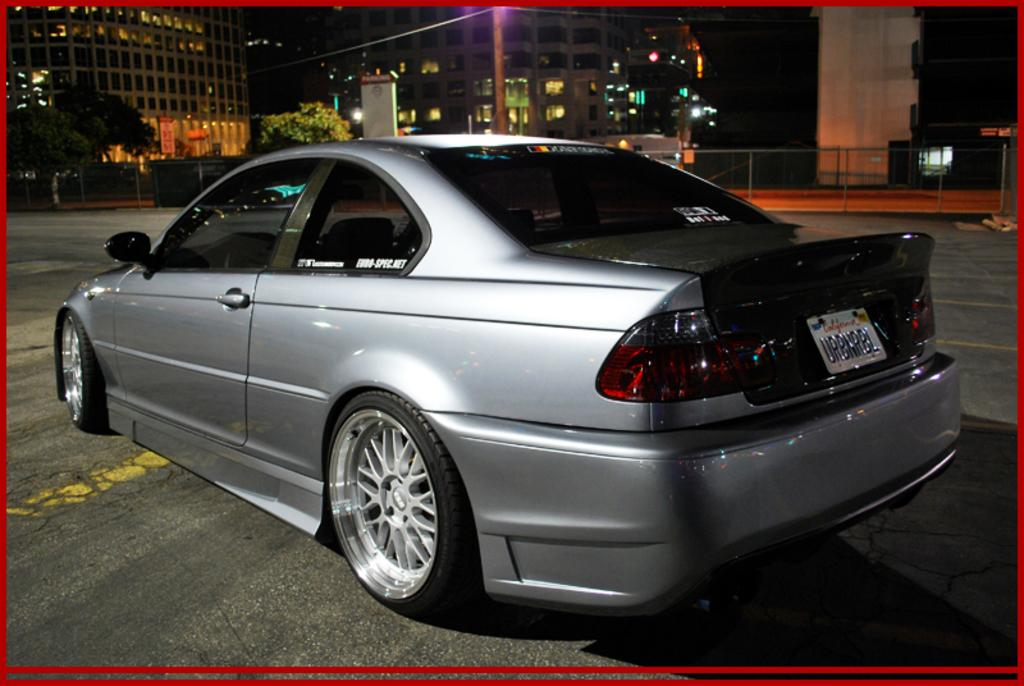What is parked on the road in the image? There is a car parked on the road in the image. What can be seen in the background of the image? There are buildings, trees, poles, and lights in the background of the image. What is the color of the border of the image? A: The border of the image has a red color. Can you see a chicken standing next to the car in the image? There is no chicken present in the image. What is the condition of the person's knee in the image? There are no people or knees visible in the image. 